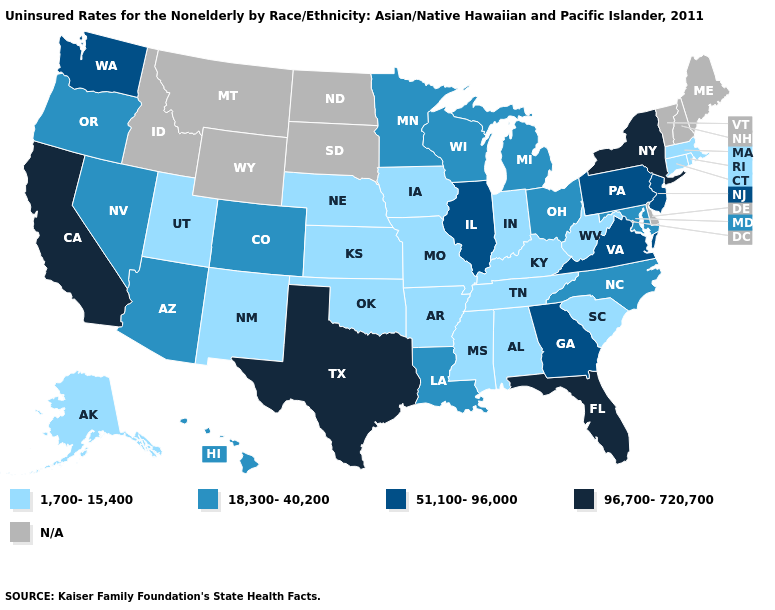Does Indiana have the lowest value in the USA?
Concise answer only. Yes. Which states have the highest value in the USA?
Short answer required. California, Florida, New York, Texas. What is the highest value in the USA?
Quick response, please. 96,700-720,700. Name the states that have a value in the range 18,300-40,200?
Short answer required. Arizona, Colorado, Hawaii, Louisiana, Maryland, Michigan, Minnesota, Nevada, North Carolina, Ohio, Oregon, Wisconsin. Does the map have missing data?
Quick response, please. Yes. What is the value of Maine?
Be succinct. N/A. Name the states that have a value in the range N/A?
Answer briefly. Delaware, Idaho, Maine, Montana, New Hampshire, North Dakota, South Dakota, Vermont, Wyoming. What is the highest value in the South ?
Answer briefly. 96,700-720,700. Name the states that have a value in the range 96,700-720,700?
Answer briefly. California, Florida, New York, Texas. What is the value of Pennsylvania?
Short answer required. 51,100-96,000. Name the states that have a value in the range 1,700-15,400?
Concise answer only. Alabama, Alaska, Arkansas, Connecticut, Indiana, Iowa, Kansas, Kentucky, Massachusetts, Mississippi, Missouri, Nebraska, New Mexico, Oklahoma, Rhode Island, South Carolina, Tennessee, Utah, West Virginia. Does the map have missing data?
Answer briefly. Yes. Among the states that border Indiana , which have the highest value?
Keep it brief. Illinois. Does the map have missing data?
Short answer required. Yes. What is the value of North Carolina?
Write a very short answer. 18,300-40,200. 